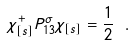Convert formula to latex. <formula><loc_0><loc_0><loc_500><loc_500>\chi _ { [ s ] } ^ { + } P ^ { \sigma } _ { 1 3 } \chi _ { [ s ] } = \frac { 1 } { 2 } \ .</formula> 